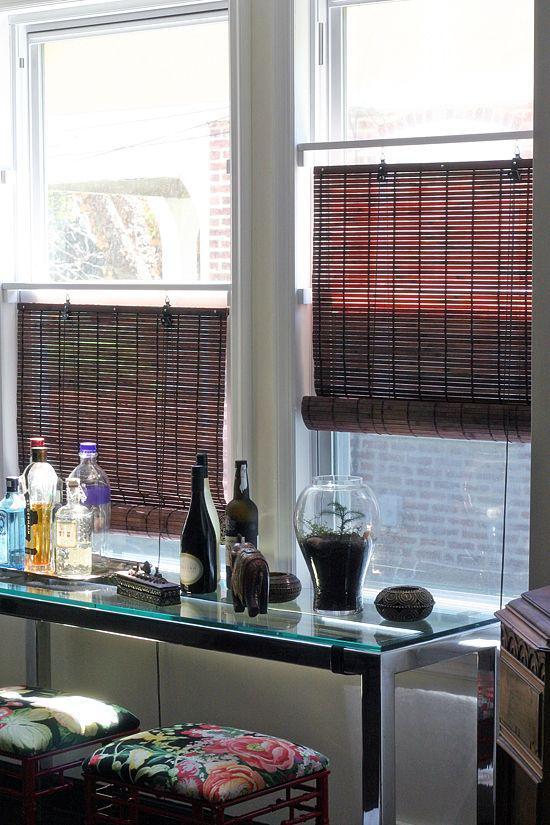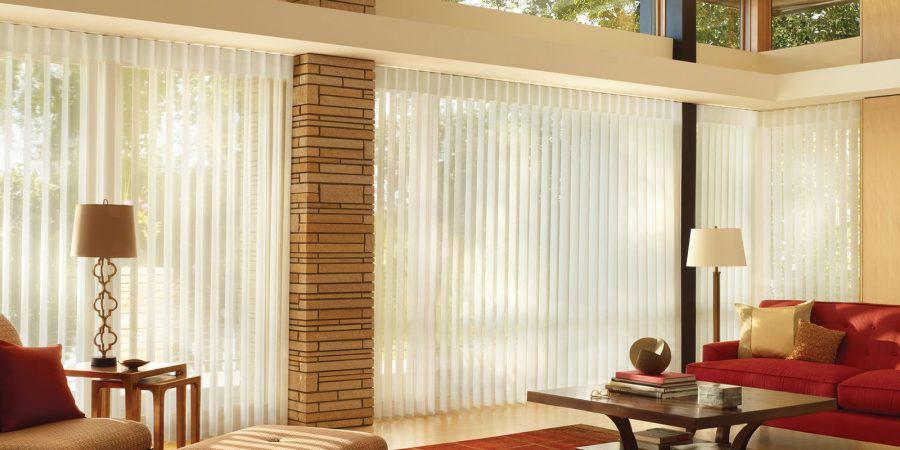The first image is the image on the left, the second image is the image on the right. Given the left and right images, does the statement "An image shows a motel-type room with beige drapes on a big window, and a TV on a wooden stand." hold true? Answer yes or no. No. 